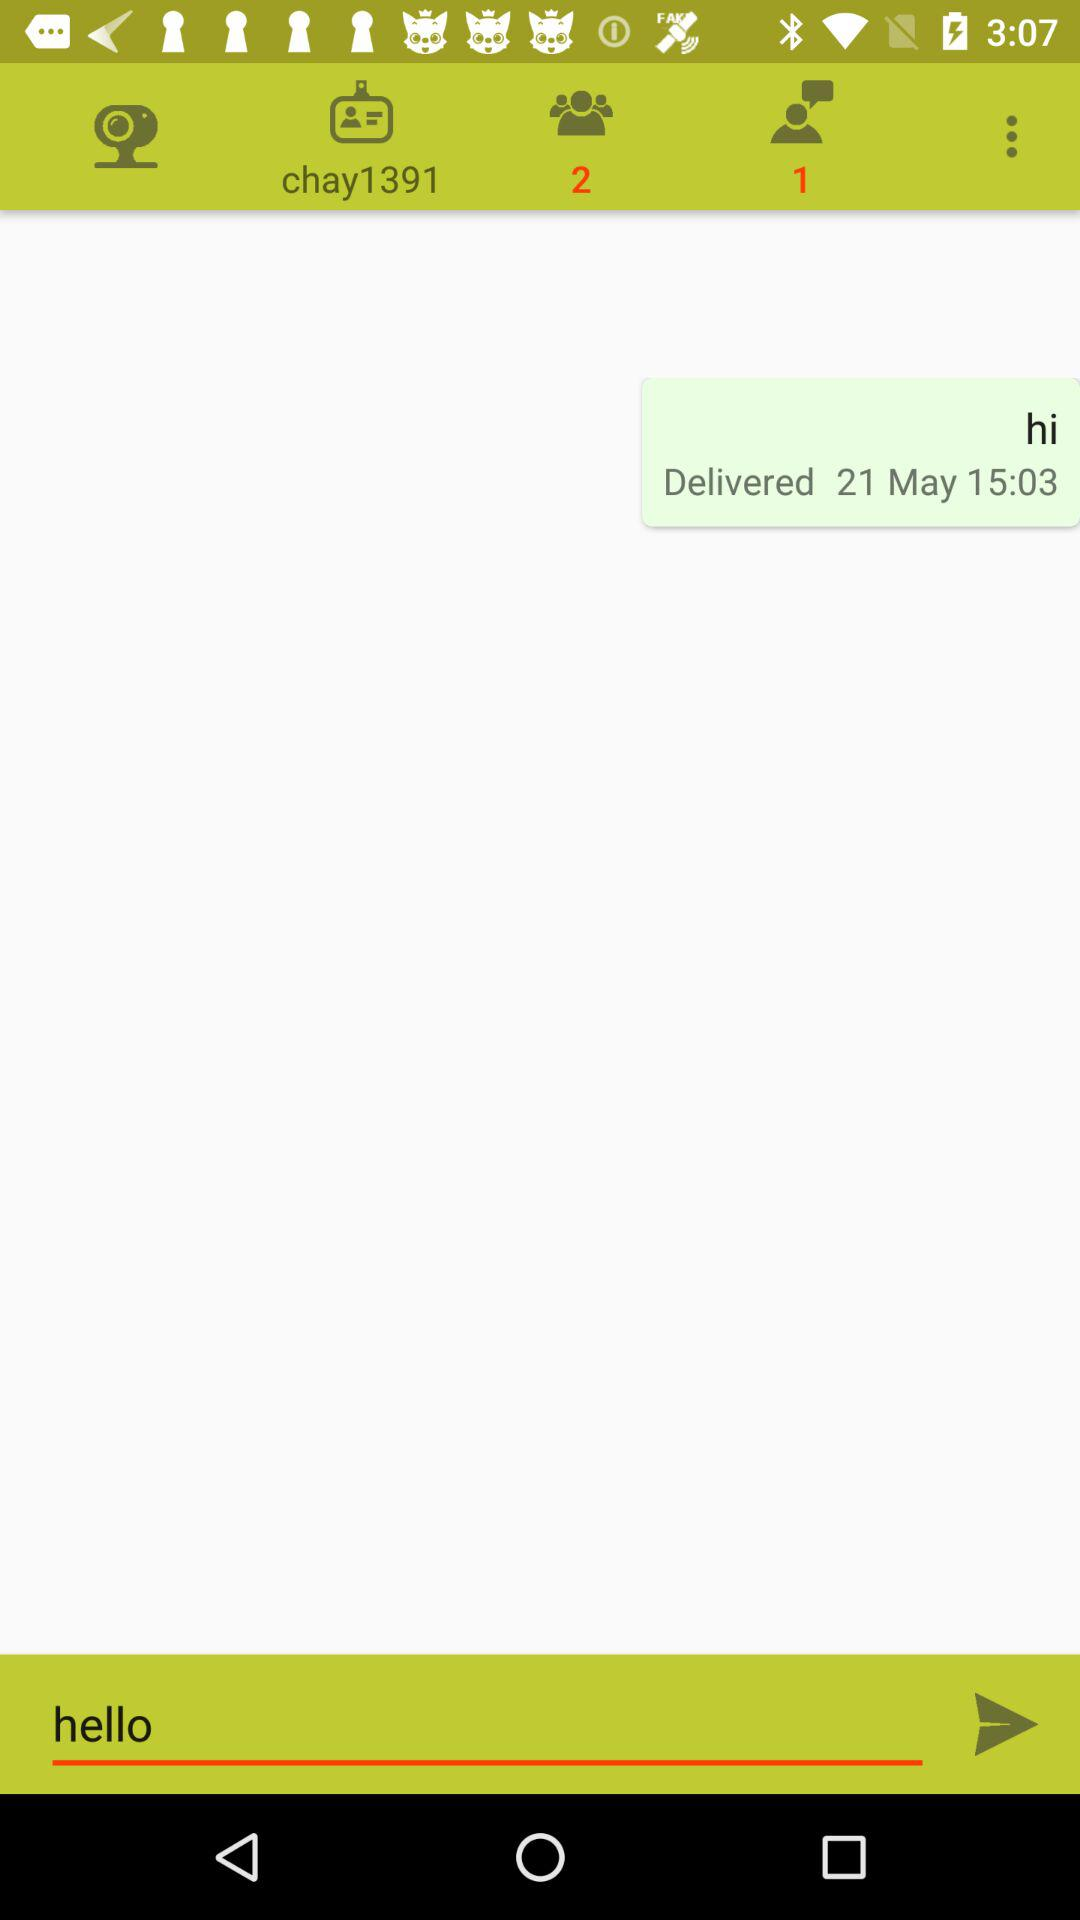What is the number of members?
When the provided information is insufficient, respond with <no answer>. <no answer> 